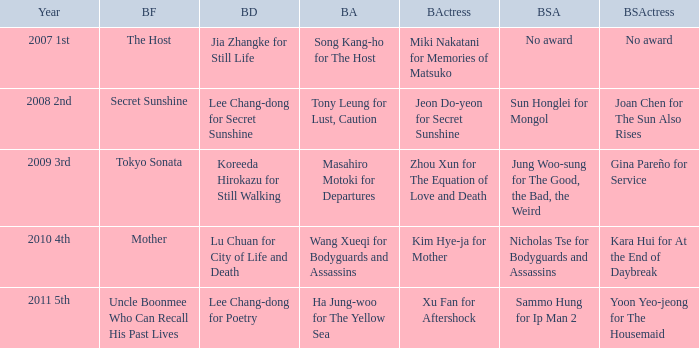Name the best director for mother Lu Chuan for City of Life and Death. 